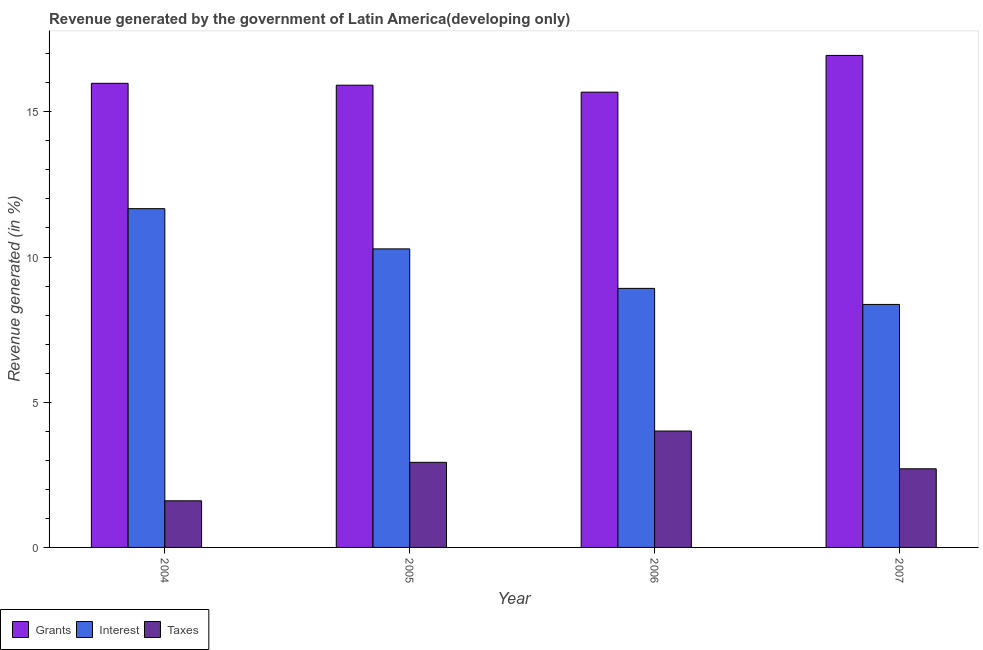How many different coloured bars are there?
Give a very brief answer. 3. How many groups of bars are there?
Make the answer very short. 4. Are the number of bars on each tick of the X-axis equal?
Give a very brief answer. Yes. How many bars are there on the 4th tick from the left?
Your answer should be compact. 3. How many bars are there on the 4th tick from the right?
Make the answer very short. 3. In how many cases, is the number of bars for a given year not equal to the number of legend labels?
Your answer should be very brief. 0. What is the percentage of revenue generated by taxes in 2004?
Ensure brevity in your answer.  1.61. Across all years, what is the maximum percentage of revenue generated by taxes?
Ensure brevity in your answer.  4.01. Across all years, what is the minimum percentage of revenue generated by grants?
Your answer should be compact. 15.68. In which year was the percentage of revenue generated by grants maximum?
Make the answer very short. 2007. What is the total percentage of revenue generated by taxes in the graph?
Your response must be concise. 11.25. What is the difference between the percentage of revenue generated by interest in 2006 and that in 2007?
Keep it short and to the point. 0.55. What is the difference between the percentage of revenue generated by grants in 2007 and the percentage of revenue generated by taxes in 2006?
Provide a short and direct response. 1.27. What is the average percentage of revenue generated by grants per year?
Provide a succinct answer. 16.13. In the year 2005, what is the difference between the percentage of revenue generated by interest and percentage of revenue generated by grants?
Give a very brief answer. 0. What is the ratio of the percentage of revenue generated by taxes in 2004 to that in 2007?
Ensure brevity in your answer.  0.59. Is the percentage of revenue generated by grants in 2006 less than that in 2007?
Your answer should be compact. Yes. Is the difference between the percentage of revenue generated by interest in 2005 and 2007 greater than the difference between the percentage of revenue generated by grants in 2005 and 2007?
Give a very brief answer. No. What is the difference between the highest and the second highest percentage of revenue generated by interest?
Give a very brief answer. 1.38. What is the difference between the highest and the lowest percentage of revenue generated by taxes?
Make the answer very short. 2.4. What does the 2nd bar from the left in 2006 represents?
Offer a terse response. Interest. What does the 2nd bar from the right in 2007 represents?
Your answer should be very brief. Interest. Is it the case that in every year, the sum of the percentage of revenue generated by grants and percentage of revenue generated by interest is greater than the percentage of revenue generated by taxes?
Keep it short and to the point. Yes. Are the values on the major ticks of Y-axis written in scientific E-notation?
Provide a succinct answer. No. What is the title of the graph?
Ensure brevity in your answer.  Revenue generated by the government of Latin America(developing only). What is the label or title of the X-axis?
Provide a succinct answer. Year. What is the label or title of the Y-axis?
Keep it short and to the point. Revenue generated (in %). What is the Revenue generated (in %) in Grants in 2004?
Your answer should be very brief. 15.98. What is the Revenue generated (in %) of Interest in 2004?
Keep it short and to the point. 11.67. What is the Revenue generated (in %) of Taxes in 2004?
Offer a terse response. 1.61. What is the Revenue generated (in %) in Grants in 2005?
Provide a short and direct response. 15.92. What is the Revenue generated (in %) of Interest in 2005?
Ensure brevity in your answer.  10.28. What is the Revenue generated (in %) in Taxes in 2005?
Your answer should be very brief. 2.93. What is the Revenue generated (in %) of Grants in 2006?
Your answer should be very brief. 15.68. What is the Revenue generated (in %) of Interest in 2006?
Ensure brevity in your answer.  8.92. What is the Revenue generated (in %) of Taxes in 2006?
Keep it short and to the point. 4.01. What is the Revenue generated (in %) in Grants in 2007?
Provide a short and direct response. 16.94. What is the Revenue generated (in %) in Interest in 2007?
Provide a short and direct response. 8.37. What is the Revenue generated (in %) in Taxes in 2007?
Make the answer very short. 2.71. Across all years, what is the maximum Revenue generated (in %) of Grants?
Your response must be concise. 16.94. Across all years, what is the maximum Revenue generated (in %) of Interest?
Provide a succinct answer. 11.67. Across all years, what is the maximum Revenue generated (in %) in Taxes?
Give a very brief answer. 4.01. Across all years, what is the minimum Revenue generated (in %) of Grants?
Offer a very short reply. 15.68. Across all years, what is the minimum Revenue generated (in %) in Interest?
Ensure brevity in your answer.  8.37. Across all years, what is the minimum Revenue generated (in %) in Taxes?
Offer a very short reply. 1.61. What is the total Revenue generated (in %) of Grants in the graph?
Give a very brief answer. 64.52. What is the total Revenue generated (in %) in Interest in the graph?
Give a very brief answer. 39.23. What is the total Revenue generated (in %) in Taxes in the graph?
Your response must be concise. 11.25. What is the difference between the Revenue generated (in %) in Grants in 2004 and that in 2005?
Keep it short and to the point. 0.06. What is the difference between the Revenue generated (in %) in Interest in 2004 and that in 2005?
Your answer should be very brief. 1.38. What is the difference between the Revenue generated (in %) of Taxes in 2004 and that in 2005?
Provide a succinct answer. -1.32. What is the difference between the Revenue generated (in %) in Grants in 2004 and that in 2006?
Offer a very short reply. 0.3. What is the difference between the Revenue generated (in %) in Interest in 2004 and that in 2006?
Offer a terse response. 2.74. What is the difference between the Revenue generated (in %) of Taxes in 2004 and that in 2006?
Offer a terse response. -2.4. What is the difference between the Revenue generated (in %) in Grants in 2004 and that in 2007?
Offer a very short reply. -0.96. What is the difference between the Revenue generated (in %) in Interest in 2004 and that in 2007?
Provide a short and direct response. 3.3. What is the difference between the Revenue generated (in %) in Taxes in 2004 and that in 2007?
Your answer should be compact. -1.1. What is the difference between the Revenue generated (in %) of Grants in 2005 and that in 2006?
Provide a short and direct response. 0.24. What is the difference between the Revenue generated (in %) in Interest in 2005 and that in 2006?
Give a very brief answer. 1.36. What is the difference between the Revenue generated (in %) in Taxes in 2005 and that in 2006?
Offer a very short reply. -1.08. What is the difference between the Revenue generated (in %) in Grants in 2005 and that in 2007?
Ensure brevity in your answer.  -1.03. What is the difference between the Revenue generated (in %) in Interest in 2005 and that in 2007?
Provide a short and direct response. 1.91. What is the difference between the Revenue generated (in %) in Taxes in 2005 and that in 2007?
Keep it short and to the point. 0.22. What is the difference between the Revenue generated (in %) of Grants in 2006 and that in 2007?
Make the answer very short. -1.26. What is the difference between the Revenue generated (in %) in Interest in 2006 and that in 2007?
Your response must be concise. 0.55. What is the difference between the Revenue generated (in %) in Taxes in 2006 and that in 2007?
Provide a succinct answer. 1.3. What is the difference between the Revenue generated (in %) in Grants in 2004 and the Revenue generated (in %) in Interest in 2005?
Ensure brevity in your answer.  5.7. What is the difference between the Revenue generated (in %) of Grants in 2004 and the Revenue generated (in %) of Taxes in 2005?
Your answer should be compact. 13.05. What is the difference between the Revenue generated (in %) of Interest in 2004 and the Revenue generated (in %) of Taxes in 2005?
Provide a short and direct response. 8.73. What is the difference between the Revenue generated (in %) of Grants in 2004 and the Revenue generated (in %) of Interest in 2006?
Your response must be concise. 7.06. What is the difference between the Revenue generated (in %) of Grants in 2004 and the Revenue generated (in %) of Taxes in 2006?
Offer a terse response. 11.97. What is the difference between the Revenue generated (in %) in Interest in 2004 and the Revenue generated (in %) in Taxes in 2006?
Your answer should be very brief. 7.66. What is the difference between the Revenue generated (in %) of Grants in 2004 and the Revenue generated (in %) of Interest in 2007?
Your answer should be very brief. 7.61. What is the difference between the Revenue generated (in %) in Grants in 2004 and the Revenue generated (in %) in Taxes in 2007?
Your answer should be very brief. 13.27. What is the difference between the Revenue generated (in %) in Interest in 2004 and the Revenue generated (in %) in Taxes in 2007?
Your response must be concise. 8.96. What is the difference between the Revenue generated (in %) in Grants in 2005 and the Revenue generated (in %) in Interest in 2006?
Ensure brevity in your answer.  7. What is the difference between the Revenue generated (in %) in Grants in 2005 and the Revenue generated (in %) in Taxes in 2006?
Your answer should be compact. 11.91. What is the difference between the Revenue generated (in %) of Interest in 2005 and the Revenue generated (in %) of Taxes in 2006?
Provide a succinct answer. 6.27. What is the difference between the Revenue generated (in %) in Grants in 2005 and the Revenue generated (in %) in Interest in 2007?
Keep it short and to the point. 7.55. What is the difference between the Revenue generated (in %) of Grants in 2005 and the Revenue generated (in %) of Taxes in 2007?
Your answer should be compact. 13.21. What is the difference between the Revenue generated (in %) of Interest in 2005 and the Revenue generated (in %) of Taxes in 2007?
Make the answer very short. 7.57. What is the difference between the Revenue generated (in %) of Grants in 2006 and the Revenue generated (in %) of Interest in 2007?
Offer a very short reply. 7.31. What is the difference between the Revenue generated (in %) of Grants in 2006 and the Revenue generated (in %) of Taxes in 2007?
Offer a very short reply. 12.97. What is the difference between the Revenue generated (in %) in Interest in 2006 and the Revenue generated (in %) in Taxes in 2007?
Provide a succinct answer. 6.21. What is the average Revenue generated (in %) of Grants per year?
Make the answer very short. 16.13. What is the average Revenue generated (in %) of Interest per year?
Provide a succinct answer. 9.81. What is the average Revenue generated (in %) in Taxes per year?
Provide a short and direct response. 2.81. In the year 2004, what is the difference between the Revenue generated (in %) in Grants and Revenue generated (in %) in Interest?
Offer a very short reply. 4.32. In the year 2004, what is the difference between the Revenue generated (in %) of Grants and Revenue generated (in %) of Taxes?
Your answer should be very brief. 14.38. In the year 2004, what is the difference between the Revenue generated (in %) of Interest and Revenue generated (in %) of Taxes?
Offer a terse response. 10.06. In the year 2005, what is the difference between the Revenue generated (in %) in Grants and Revenue generated (in %) in Interest?
Your answer should be compact. 5.64. In the year 2005, what is the difference between the Revenue generated (in %) of Grants and Revenue generated (in %) of Taxes?
Offer a very short reply. 12.99. In the year 2005, what is the difference between the Revenue generated (in %) in Interest and Revenue generated (in %) in Taxes?
Make the answer very short. 7.35. In the year 2006, what is the difference between the Revenue generated (in %) of Grants and Revenue generated (in %) of Interest?
Your response must be concise. 6.76. In the year 2006, what is the difference between the Revenue generated (in %) in Grants and Revenue generated (in %) in Taxes?
Provide a succinct answer. 11.67. In the year 2006, what is the difference between the Revenue generated (in %) of Interest and Revenue generated (in %) of Taxes?
Your answer should be compact. 4.91. In the year 2007, what is the difference between the Revenue generated (in %) of Grants and Revenue generated (in %) of Interest?
Offer a terse response. 8.57. In the year 2007, what is the difference between the Revenue generated (in %) of Grants and Revenue generated (in %) of Taxes?
Provide a short and direct response. 14.23. In the year 2007, what is the difference between the Revenue generated (in %) of Interest and Revenue generated (in %) of Taxes?
Give a very brief answer. 5.66. What is the ratio of the Revenue generated (in %) of Grants in 2004 to that in 2005?
Offer a terse response. 1. What is the ratio of the Revenue generated (in %) in Interest in 2004 to that in 2005?
Provide a short and direct response. 1.13. What is the ratio of the Revenue generated (in %) of Taxes in 2004 to that in 2005?
Make the answer very short. 0.55. What is the ratio of the Revenue generated (in %) of Grants in 2004 to that in 2006?
Provide a succinct answer. 1.02. What is the ratio of the Revenue generated (in %) in Interest in 2004 to that in 2006?
Provide a short and direct response. 1.31. What is the ratio of the Revenue generated (in %) in Taxes in 2004 to that in 2006?
Keep it short and to the point. 0.4. What is the ratio of the Revenue generated (in %) in Grants in 2004 to that in 2007?
Offer a very short reply. 0.94. What is the ratio of the Revenue generated (in %) of Interest in 2004 to that in 2007?
Your answer should be compact. 1.39. What is the ratio of the Revenue generated (in %) in Taxes in 2004 to that in 2007?
Offer a terse response. 0.59. What is the ratio of the Revenue generated (in %) in Grants in 2005 to that in 2006?
Give a very brief answer. 1.02. What is the ratio of the Revenue generated (in %) in Interest in 2005 to that in 2006?
Your answer should be very brief. 1.15. What is the ratio of the Revenue generated (in %) in Taxes in 2005 to that in 2006?
Give a very brief answer. 0.73. What is the ratio of the Revenue generated (in %) of Grants in 2005 to that in 2007?
Ensure brevity in your answer.  0.94. What is the ratio of the Revenue generated (in %) in Interest in 2005 to that in 2007?
Offer a very short reply. 1.23. What is the ratio of the Revenue generated (in %) of Taxes in 2005 to that in 2007?
Provide a short and direct response. 1.08. What is the ratio of the Revenue generated (in %) of Grants in 2006 to that in 2007?
Provide a short and direct response. 0.93. What is the ratio of the Revenue generated (in %) of Interest in 2006 to that in 2007?
Your response must be concise. 1.07. What is the ratio of the Revenue generated (in %) of Taxes in 2006 to that in 2007?
Offer a terse response. 1.48. What is the difference between the highest and the second highest Revenue generated (in %) of Grants?
Ensure brevity in your answer.  0.96. What is the difference between the highest and the second highest Revenue generated (in %) of Interest?
Your answer should be very brief. 1.38. What is the difference between the highest and the second highest Revenue generated (in %) of Taxes?
Ensure brevity in your answer.  1.08. What is the difference between the highest and the lowest Revenue generated (in %) in Grants?
Your answer should be compact. 1.26. What is the difference between the highest and the lowest Revenue generated (in %) in Interest?
Give a very brief answer. 3.3. What is the difference between the highest and the lowest Revenue generated (in %) of Taxes?
Provide a succinct answer. 2.4. 